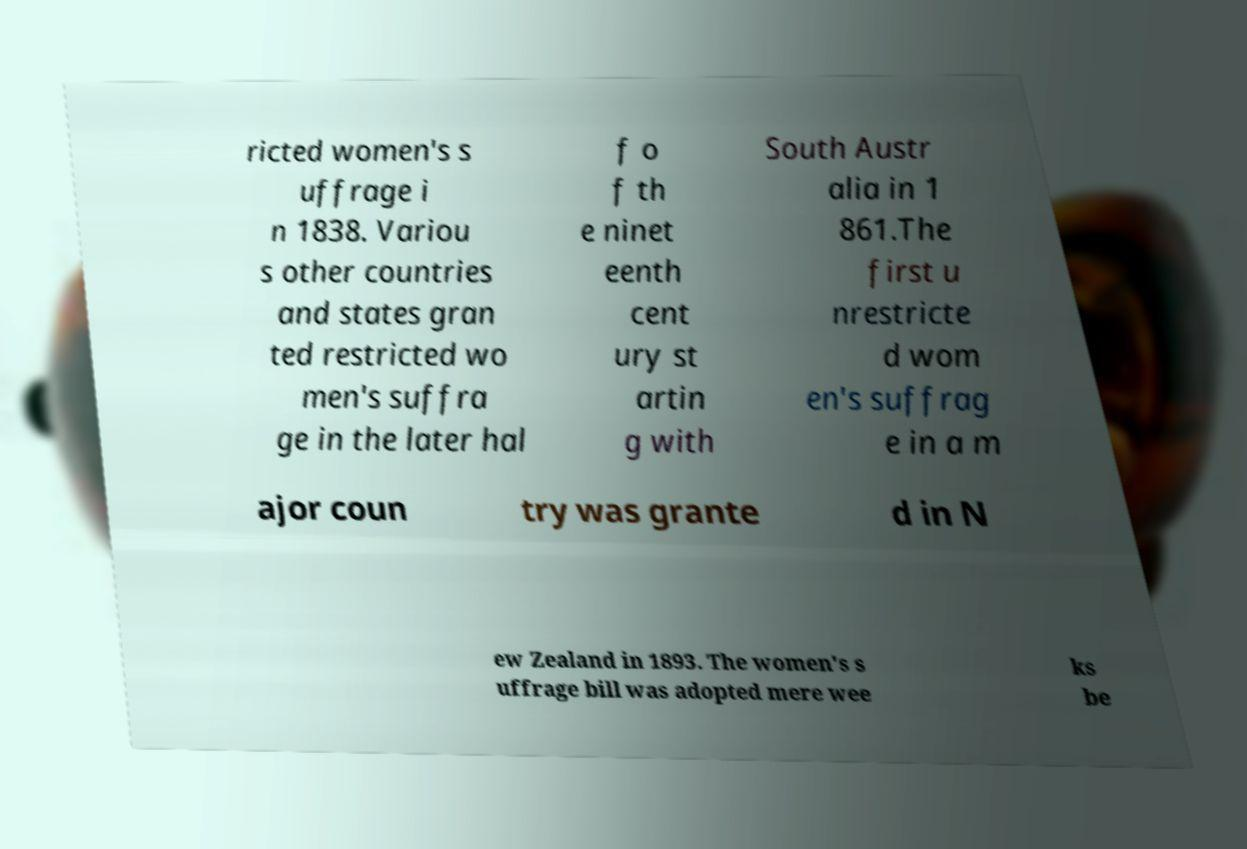Please read and relay the text visible in this image. What does it say? ricted women's s uffrage i n 1838. Variou s other countries and states gran ted restricted wo men's suffra ge in the later hal f o f th e ninet eenth cent ury st artin g with South Austr alia in 1 861.The first u nrestricte d wom en's suffrag e in a m ajor coun try was grante d in N ew Zealand in 1893. The women's s uffrage bill was adopted mere wee ks be 